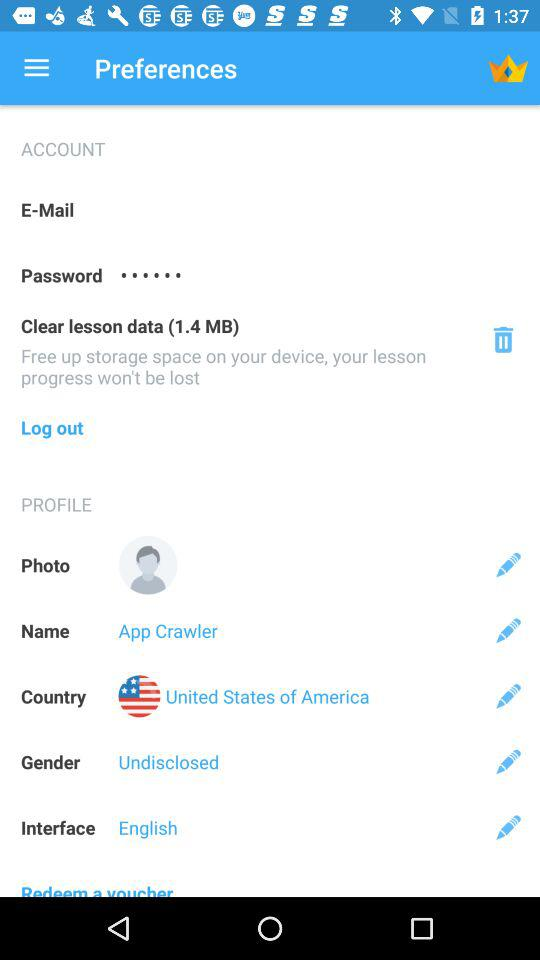What is the name of the user? The name of the user is App Crawler. 